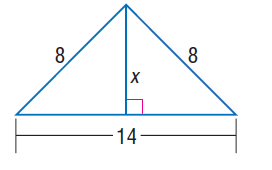Answer the mathemtical geometry problem and directly provide the correct option letter.
Question: Find x.
Choices: A: \sqrt { 15 } B: 6 C: \sqrt { 83 } D: 10 A 